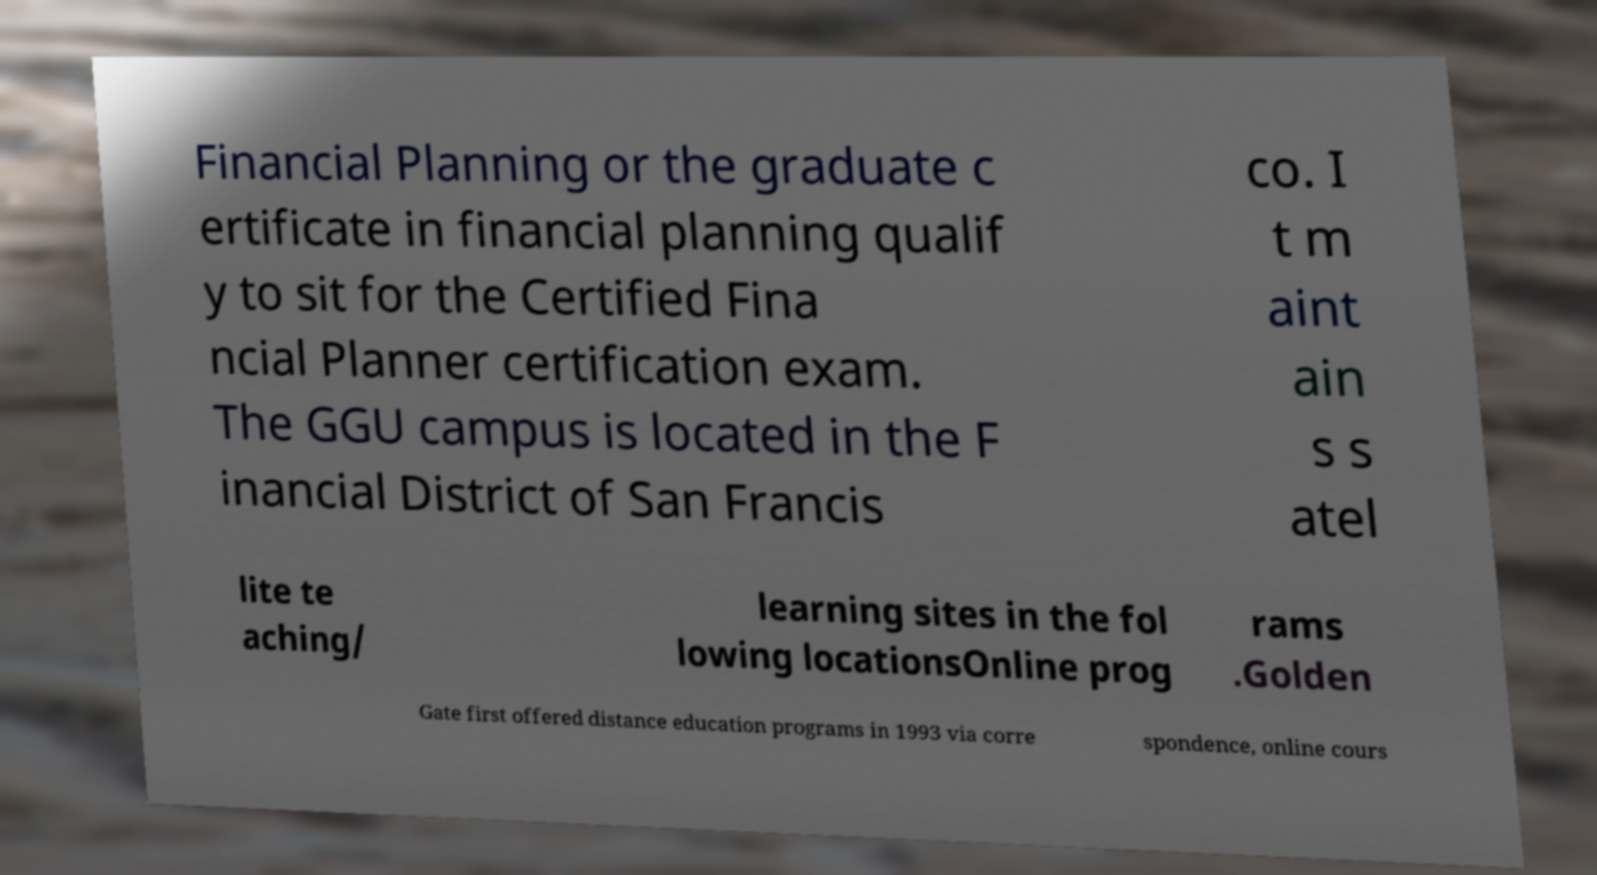Can you accurately transcribe the text from the provided image for me? Financial Planning or the graduate c ertificate in financial planning qualif y to sit for the Certified Fina ncial Planner certification exam. The GGU campus is located in the F inancial District of San Francis co. I t m aint ain s s atel lite te aching/ learning sites in the fol lowing locationsOnline prog rams .Golden Gate first offered distance education programs in 1993 via corre spondence, online cours 